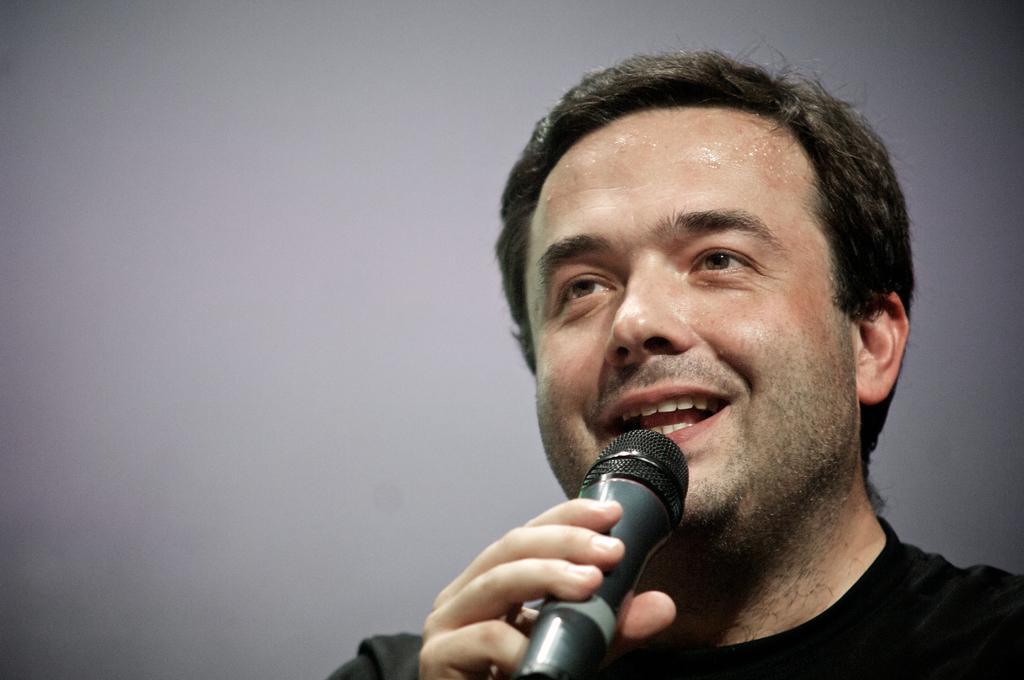Please provide a concise description of this image. In this picture we can see a man who is talking on the mike. 